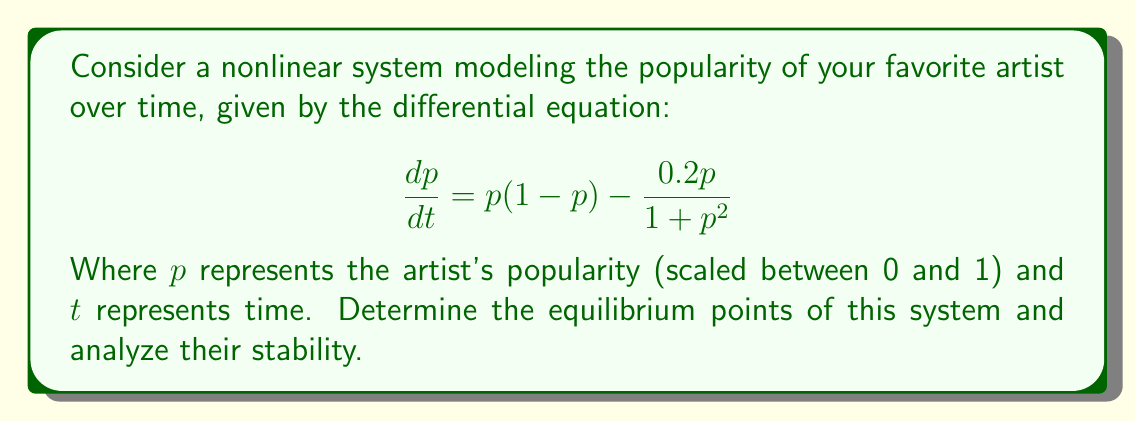Teach me how to tackle this problem. 1. Find the equilibrium points by setting $\frac{dp}{dt} = 0$:

   $$p(1-p) - \frac{0.2p}{1+p^2} = 0$$

2. Factor out $p$:

   $$p\left(1-p - \frac{0.2}{1+p^2}\right) = 0$$

3. Solve for $p$:
   a) $p = 0$ is one equilibrium point.
   b) For the other point(s), solve:

   $$1-p - \frac{0.2}{1+p^2} = 0$$

   This is a complex equation that requires numerical methods to solve. Using a numerical solver, we find that $p \approx 0.8095$ is another equilibrium point.

4. Analyze stability by evaluating the derivative of $\frac{dp}{dt}$ with respect to $p$ at each equilibrium point:

   $$\frac{d}{dp}\left(\frac{dp}{dt}\right) = (1-p) + p(-1) - \frac{0.2(1+p^2) - 0.2p(2p)}{(1+p^2)^2}$$
   $$= 1 - 2p - \frac{0.2 - 0.2p^2}{(1+p^2)^2}$$

5. Evaluate at $p = 0$:

   $$\left.\frac{d}{dp}\left(\frac{dp}{dt}\right)\right|_{p=0} = 1 - 0.2 = 0.8 > 0$$

   This indicates that $p = 0$ is an unstable equilibrium point.

6. Evaluate at $p \approx 0.8095$:

   $$\left.\frac{d}{dp}\left(\frac{dp}{dt}\right)\right|_{p=0.8095} \approx -0.3795 < 0$$

   This indicates that $p \approx 0.8095$ is a stable equilibrium point.
Answer: Two equilibrium points: $p = 0$ (unstable) and $p \approx 0.8095$ (stable). 